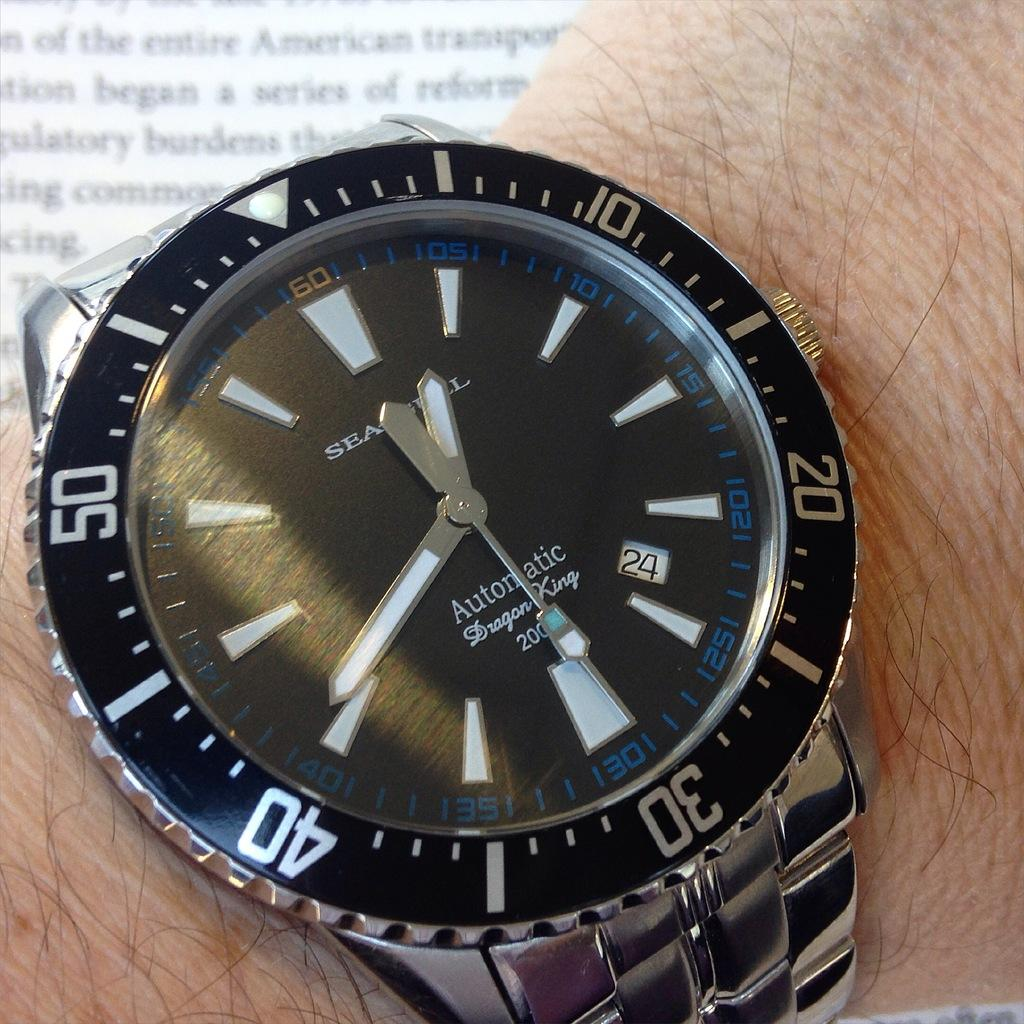<image>
Write a terse but informative summary of the picture. Wristwatch that says the word Automatic on the face. 